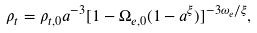<formula> <loc_0><loc_0><loc_500><loc_500>\rho _ { t } = \rho _ { t , 0 } a ^ { - 3 } [ 1 - \Omega _ { e , 0 } ( 1 - a ^ { \xi } ) ] ^ { - 3 \omega _ { e } / \xi } ,</formula> 